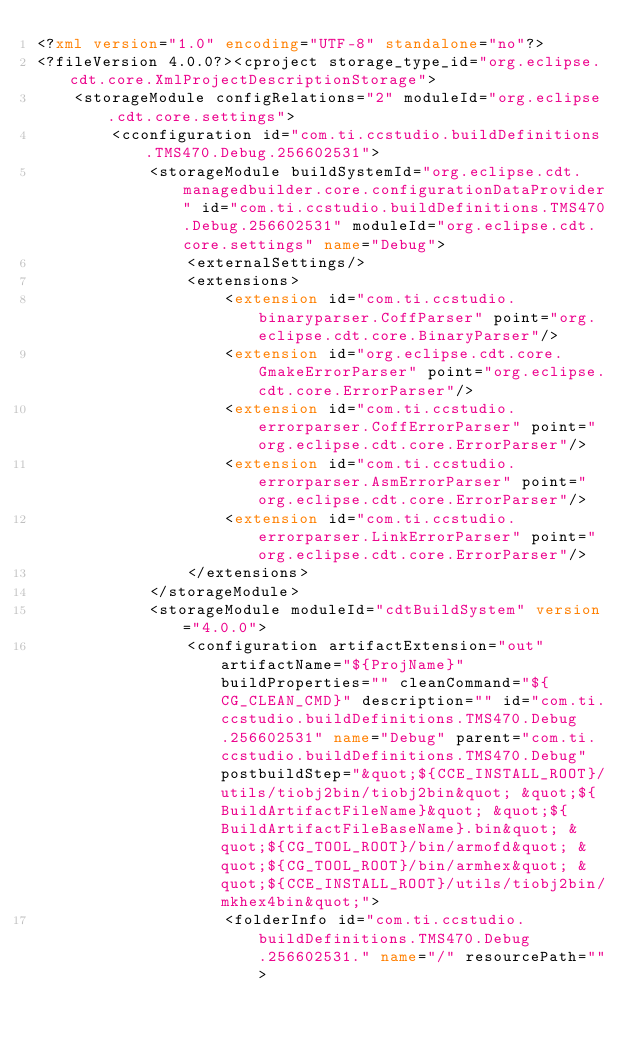<code> <loc_0><loc_0><loc_500><loc_500><_XML_><?xml version="1.0" encoding="UTF-8" standalone="no"?>
<?fileVersion 4.0.0?><cproject storage_type_id="org.eclipse.cdt.core.XmlProjectDescriptionStorage">
	<storageModule configRelations="2" moduleId="org.eclipse.cdt.core.settings">
		<cconfiguration id="com.ti.ccstudio.buildDefinitions.TMS470.Debug.256602531">
			<storageModule buildSystemId="org.eclipse.cdt.managedbuilder.core.configurationDataProvider" id="com.ti.ccstudio.buildDefinitions.TMS470.Debug.256602531" moduleId="org.eclipse.cdt.core.settings" name="Debug">
				<externalSettings/>
				<extensions>
					<extension id="com.ti.ccstudio.binaryparser.CoffParser" point="org.eclipse.cdt.core.BinaryParser"/>
					<extension id="org.eclipse.cdt.core.GmakeErrorParser" point="org.eclipse.cdt.core.ErrorParser"/>
					<extension id="com.ti.ccstudio.errorparser.CoffErrorParser" point="org.eclipse.cdt.core.ErrorParser"/>
					<extension id="com.ti.ccstudio.errorparser.AsmErrorParser" point="org.eclipse.cdt.core.ErrorParser"/>
					<extension id="com.ti.ccstudio.errorparser.LinkErrorParser" point="org.eclipse.cdt.core.ErrorParser"/>
				</extensions>
			</storageModule>
			<storageModule moduleId="cdtBuildSystem" version="4.0.0">
				<configuration artifactExtension="out" artifactName="${ProjName}" buildProperties="" cleanCommand="${CG_CLEAN_CMD}" description="" id="com.ti.ccstudio.buildDefinitions.TMS470.Debug.256602531" name="Debug" parent="com.ti.ccstudio.buildDefinitions.TMS470.Debug" postbuildStep="&quot;${CCE_INSTALL_ROOT}/utils/tiobj2bin/tiobj2bin&quot; &quot;${BuildArtifactFileName}&quot; &quot;${BuildArtifactFileBaseName}.bin&quot; &quot;${CG_TOOL_ROOT}/bin/armofd&quot; &quot;${CG_TOOL_ROOT}/bin/armhex&quot; &quot;${CCE_INSTALL_ROOT}/utils/tiobj2bin/mkhex4bin&quot;">
					<folderInfo id="com.ti.ccstudio.buildDefinitions.TMS470.Debug.256602531." name="/" resourcePath=""></code> 